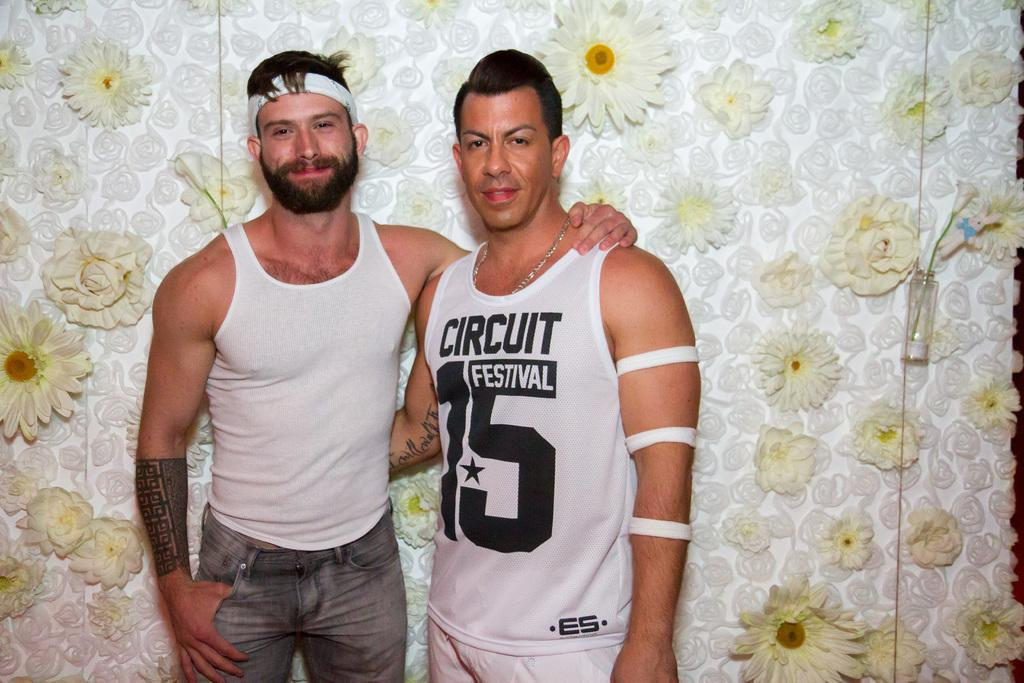<image>
Describe the image concisely. Circuit Festival 15 is printed on the tank top of this gentleman. 